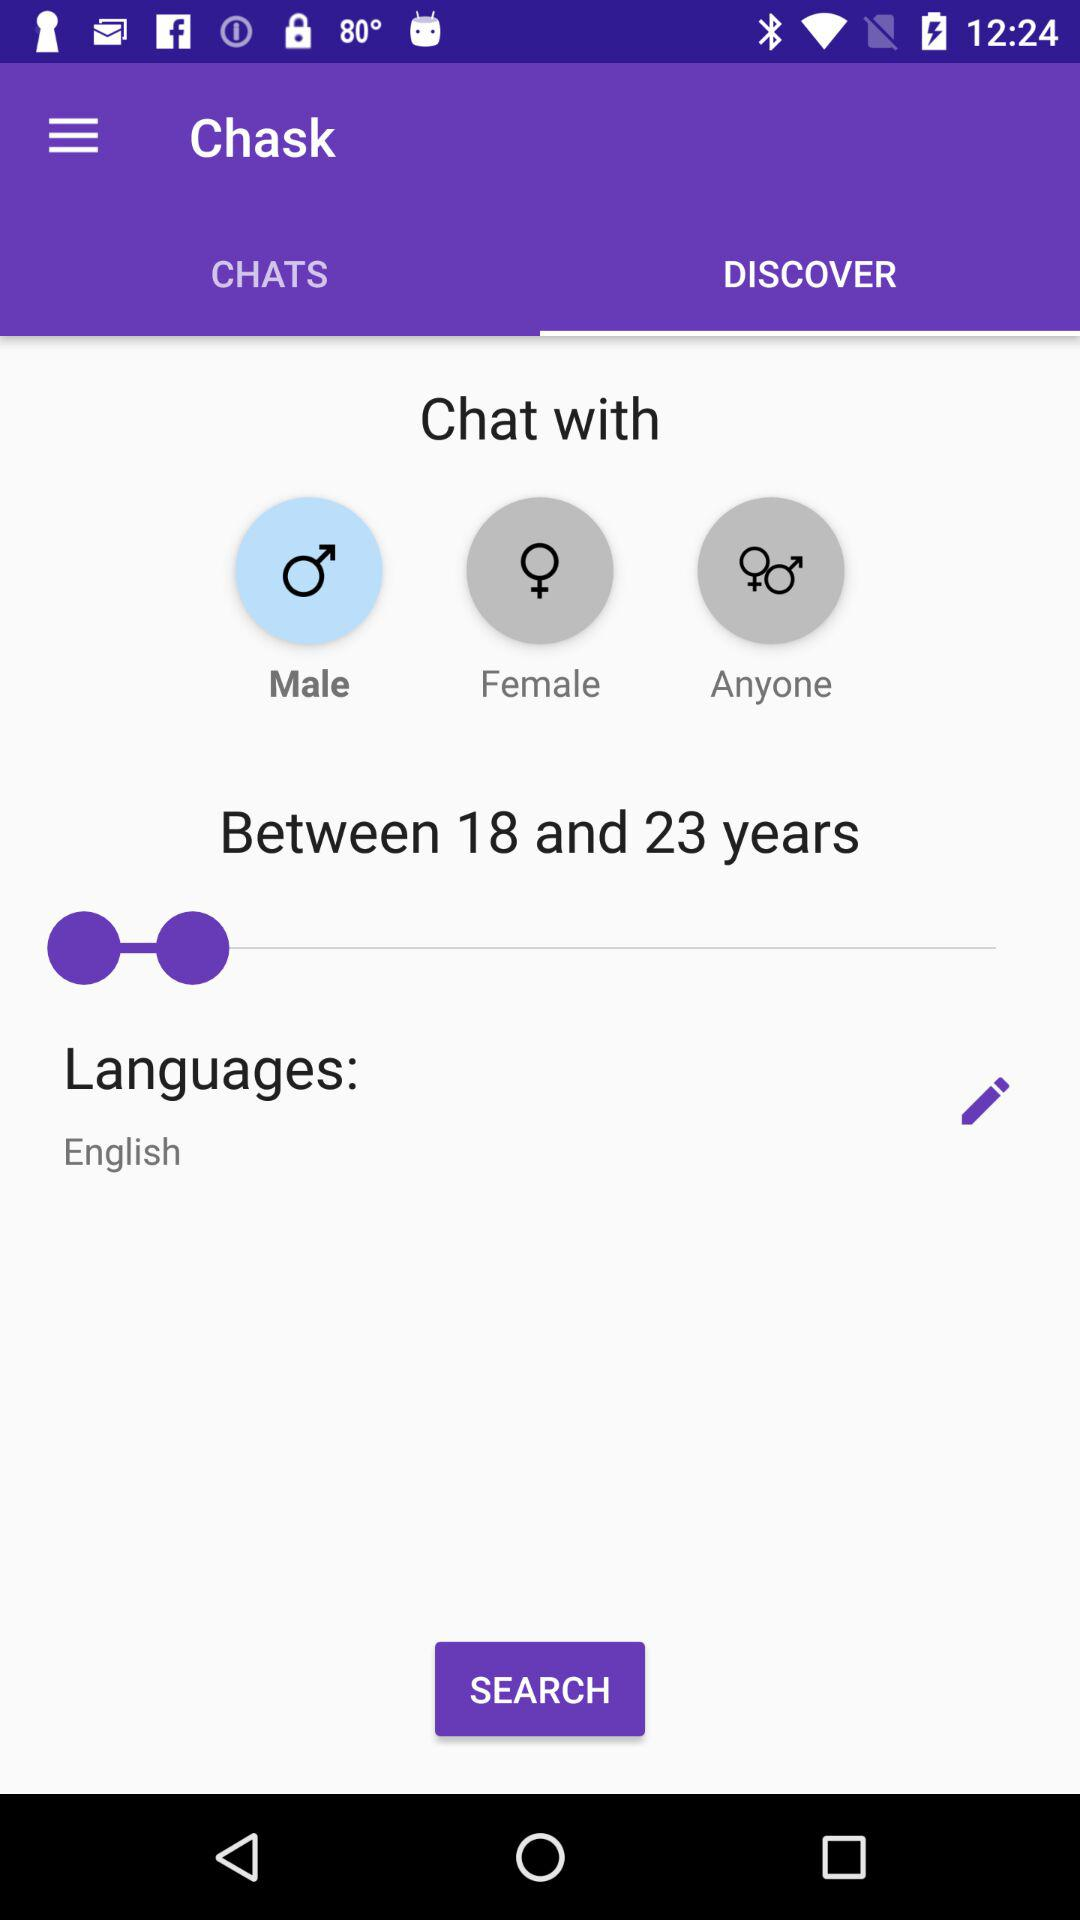What is the selected tab? The selected tab is "DISCOVER". 